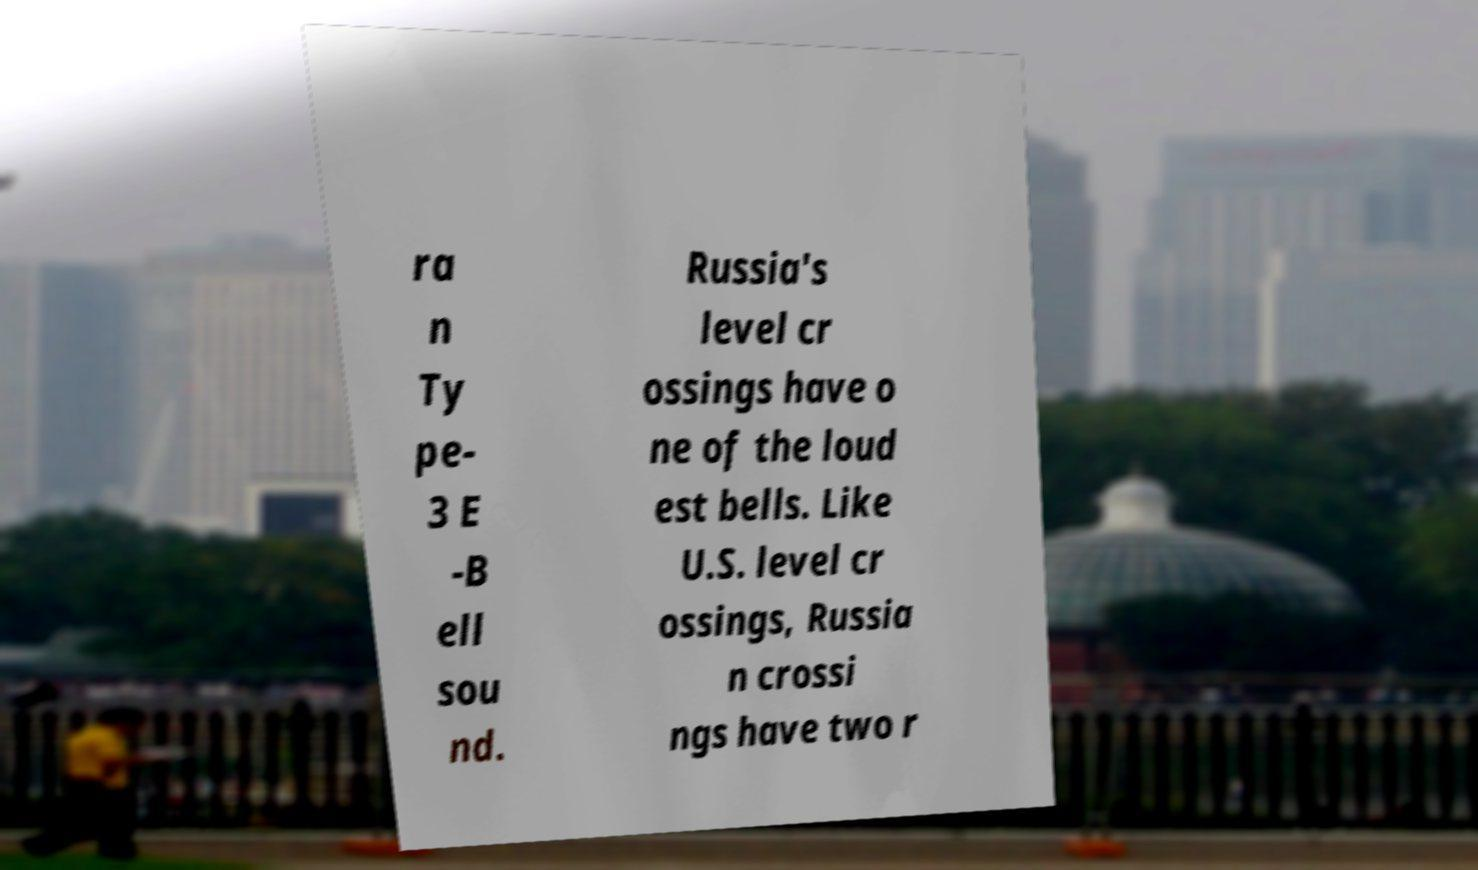Please identify and transcribe the text found in this image. ra n Ty pe- 3 E -B ell sou nd. Russia's level cr ossings have o ne of the loud est bells. Like U.S. level cr ossings, Russia n crossi ngs have two r 